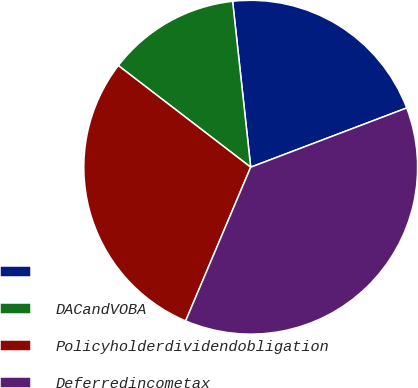<chart> <loc_0><loc_0><loc_500><loc_500><pie_chart><ecel><fcel>DACandVOBA<fcel>Policyholderdividendobligation<fcel>Deferredincometax<nl><fcel>20.95%<fcel>12.85%<fcel>29.05%<fcel>37.15%<nl></chart> 